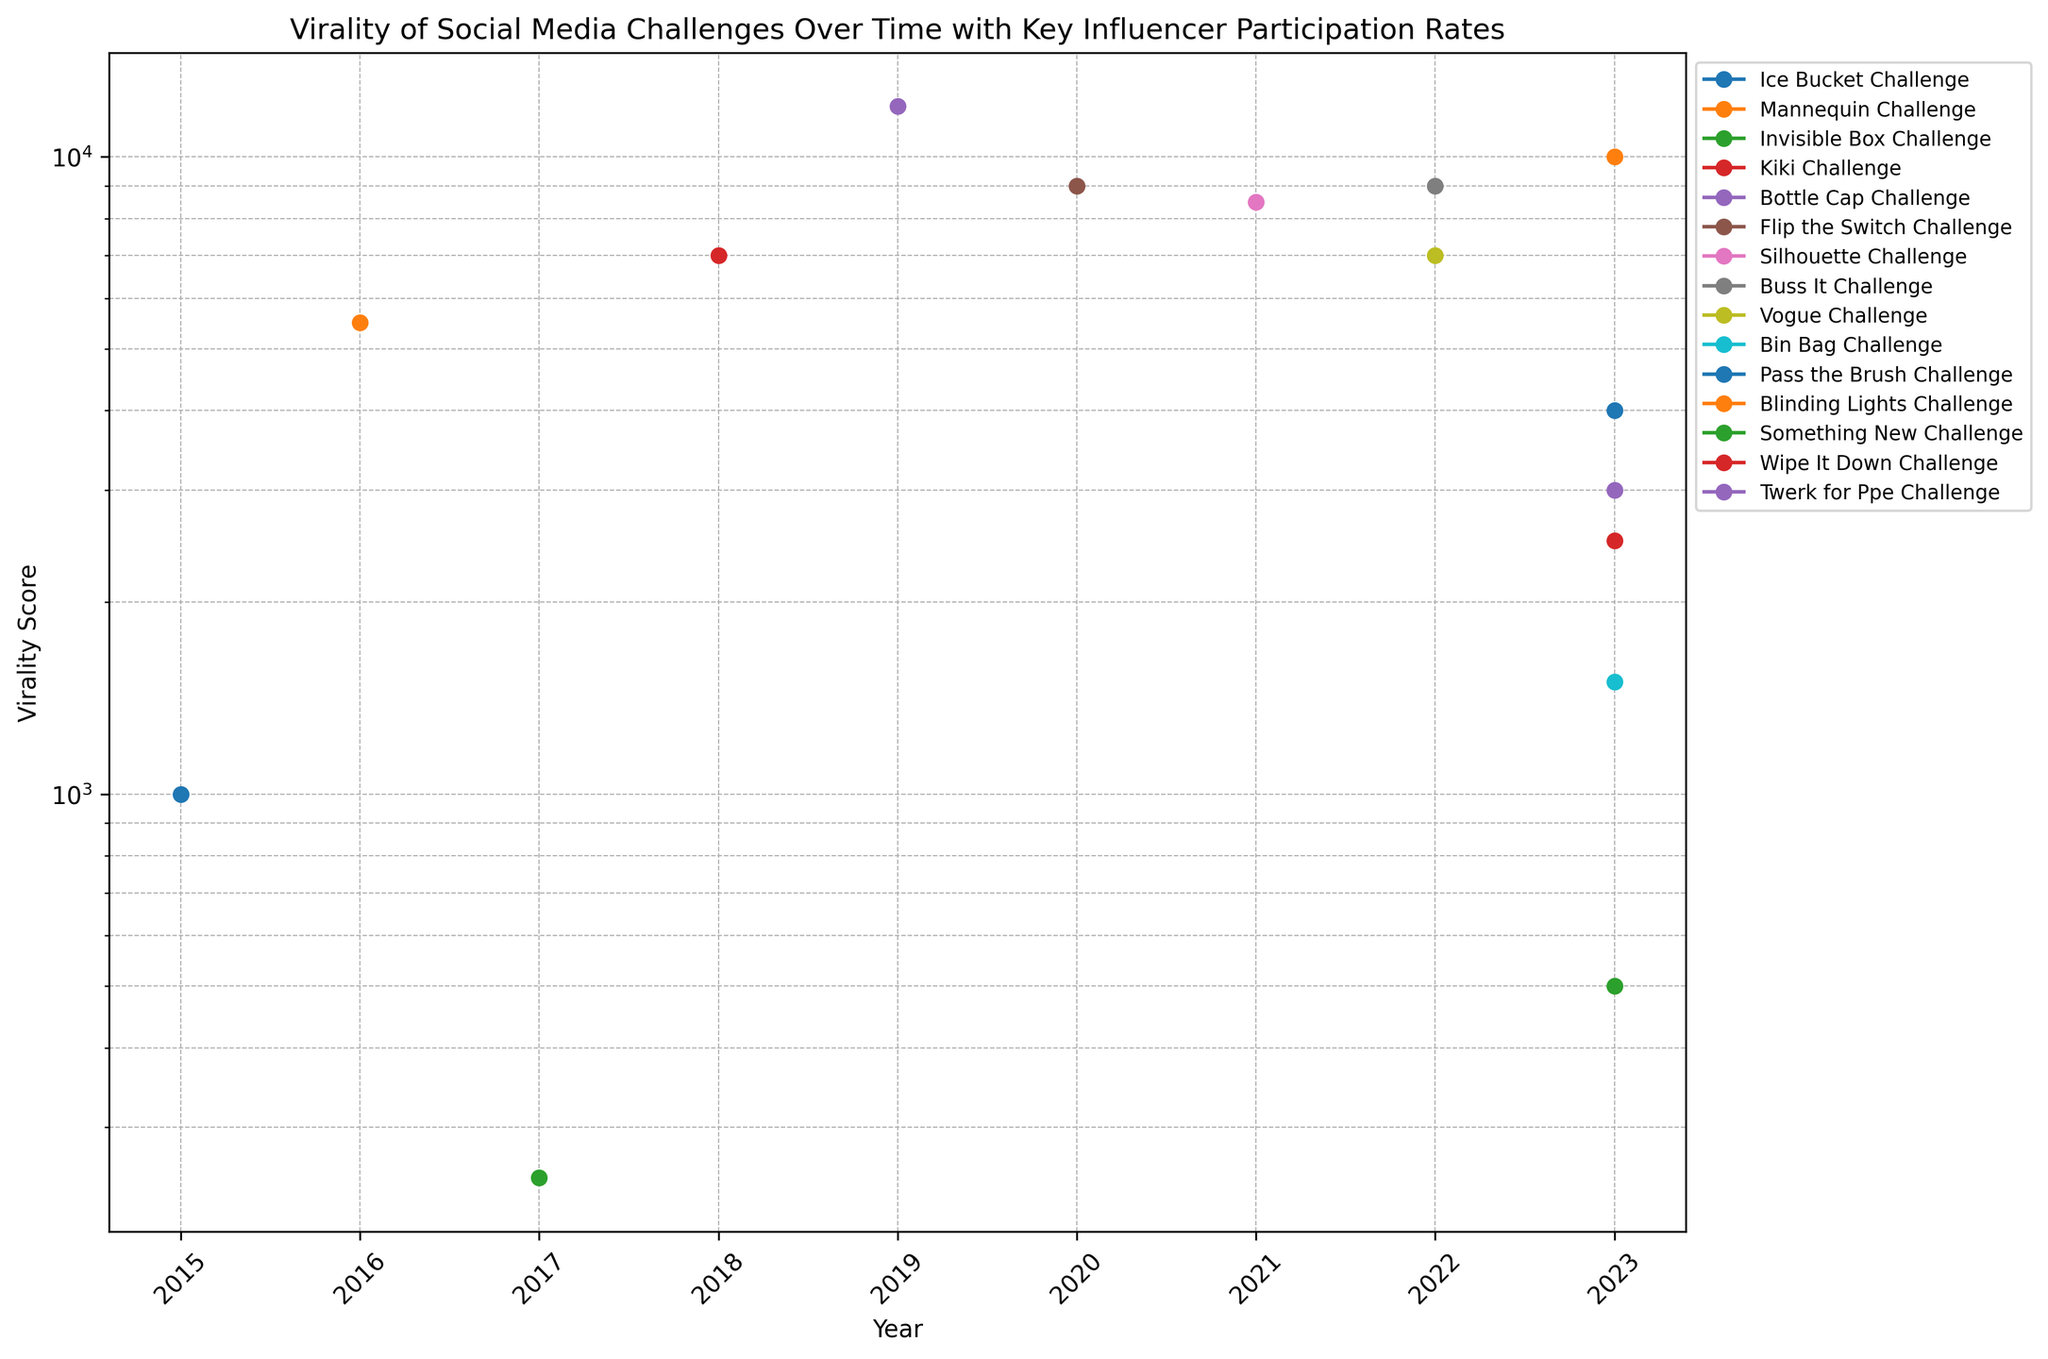What challenge had the highest Virality Score in 2019? The data shows the year and corresponding Virality Scores for each social media challenge. For 2019, we compare the Virality Scores of the listed challenges. The Bottle Cap Challenge had the highest score.
Answer: Bottle Cap Challenge Compare the Virality Scores of the Ice Bucket Challenge and the Blinding Lights Challenge. Which one is higher and by how much? By looking at the plotted points, identify the Virality Scores for Ice Bucket Challenge (1000) and Blinding Lights Challenge (10000). Calculate the difference: 10000 - 1000 = 9000.
Answer: Blinding Lights Challenge, by 9000 Among the challenges in 2023, which one had the lowest Virality Score? Look at the plotted data points for the year 2023 and identify the challenges. Compare their Virality Scores and the lowest is for Something New Challenge (500).
Answer: Something New Challenge What is the general trend in Virality Score for challenges as the Influencer Participation Rate increases over the years? Generally, an increasing trend in Virality Score can be observed as the Influencer Participation Rate increases, as inferred from higher participation (e.g., Buss It Challenge) leading to higher Virality Scores compared to earlier years with lower participation rates (e.g., Ice Bucket Challenge).
Answer: Increasing trend What is the average Virality Score of challenges in 2022? Identify the Virality Scores of challenges in 2022: Buss It Challenge (9000) and Vogue Challenge (7000). Compute the average: (9000 + 7000) / 2 = 8000.
Answer: 8000 Between the Mannequin Challenge and the Flip the Switch Challenge, which had a higher Virality Score and by what percentage difference? Compare the Virality Scores of Mannequin Challenge (5500) and Flip the Switch Challenge (9000). Calculate the percentage difference: ((9000 - 5500) / 5500) * 100 ≈ 63.64%.
Answer: Flip the Switch Challenge, by approximately 63.64% Which challenge experienced the highest increase in Virality Score compared to its immediate predecessor year? Evaluate the year-on-year changes in Virality Scores and identify the highest increase. The Kiki Challenge in 2018 (7000) compared to Invisible Box Challenge in 2017 (250), shows the highest increase (7000 - 250 = 6750).
Answer: Kiki Challenge, increase of 6750 What challenge in 2023 had a Virality Score closest to the Kiki Challenge in 2018? Identify the Kiki Challenge Virality Score in 2018 (7000) and compare it with the scores in 2023. The Blinding Lights Challenge in 2023 had a Virality Score of 10000, closest to Kiki Challenge.
Answer: Blinding Lights Challenge How many challenges had a Virality Score greater than 5000? Count the number of challenges with Virality Scores greater than 5000. Mannequin Challenge (5500), Kiki Challenge (7000), Bottle Cap Challenge (12000), Flip the Switch Challenge (9000), Silhouette Challenge (8500), Buss It Challenge (9000), and Blinding Lights Challenge (10000). There are 7 challenges in total.
Answer: 7 Between Ice Bucket Challenge and Pass the Brush Challenge, which one showed a higher participation rate from key influencers? Compare Influencer Participation Rates of Ice Bucket Challenge (0.15) and Pass the Brush Challenge (0.35). Pass the Brush Challenge had a higher participation rate.
Answer: Pass the Brush Challenge 